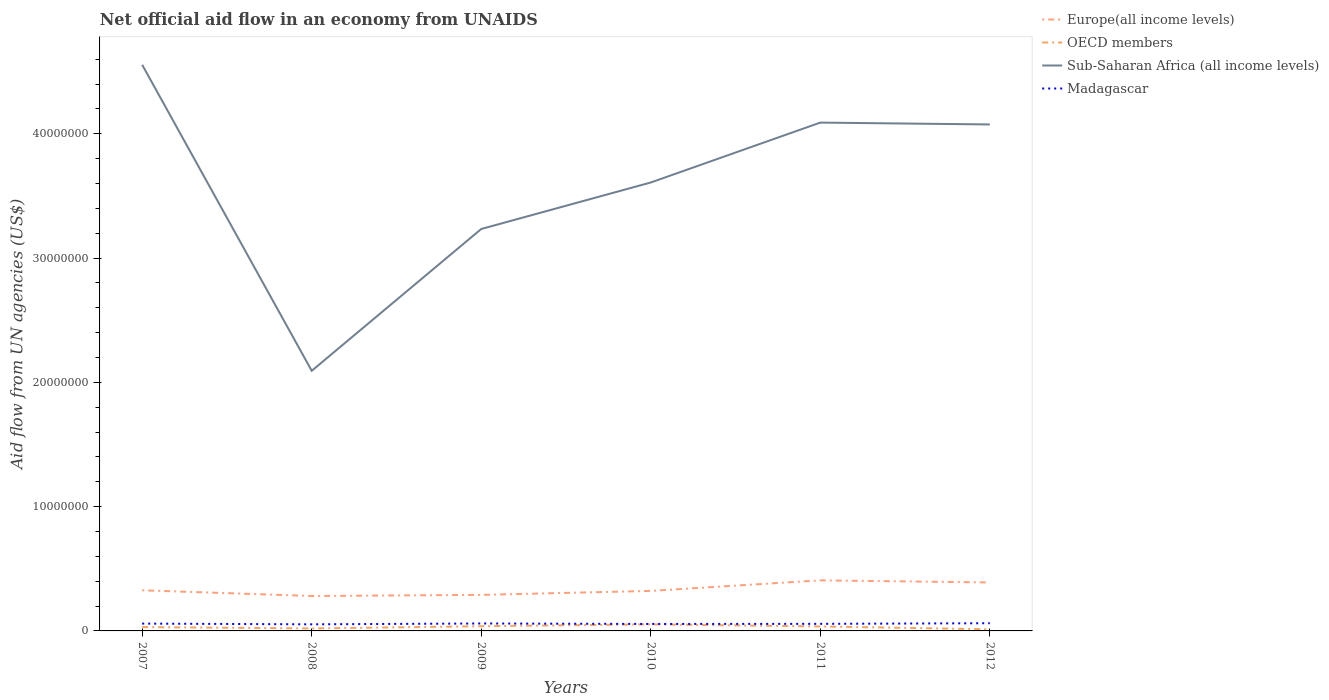How many different coloured lines are there?
Ensure brevity in your answer.  4. Is the number of lines equal to the number of legend labels?
Offer a terse response. Yes. Across all years, what is the maximum net official aid flow in OECD members?
Make the answer very short. 1.30e+05. What is the total net official aid flow in Madagascar in the graph?
Your answer should be compact. -9.00e+04. What is the difference between the highest and the second highest net official aid flow in OECD members?
Ensure brevity in your answer.  4.00e+05. Is the net official aid flow in Europe(all income levels) strictly greater than the net official aid flow in OECD members over the years?
Your response must be concise. No. How many years are there in the graph?
Your answer should be very brief. 6. Are the values on the major ticks of Y-axis written in scientific E-notation?
Provide a succinct answer. No. Does the graph contain any zero values?
Your answer should be very brief. No. Does the graph contain grids?
Offer a very short reply. No. Where does the legend appear in the graph?
Offer a very short reply. Top right. How many legend labels are there?
Offer a terse response. 4. How are the legend labels stacked?
Offer a terse response. Vertical. What is the title of the graph?
Offer a terse response. Net official aid flow in an economy from UNAIDS. Does "China" appear as one of the legend labels in the graph?
Your answer should be compact. No. What is the label or title of the Y-axis?
Ensure brevity in your answer.  Aid flow from UN agencies (US$). What is the Aid flow from UN agencies (US$) in Europe(all income levels) in 2007?
Provide a short and direct response. 3.27e+06. What is the Aid flow from UN agencies (US$) of Sub-Saharan Africa (all income levels) in 2007?
Provide a short and direct response. 4.56e+07. What is the Aid flow from UN agencies (US$) in Madagascar in 2007?
Offer a terse response. 5.90e+05. What is the Aid flow from UN agencies (US$) of Europe(all income levels) in 2008?
Make the answer very short. 2.81e+06. What is the Aid flow from UN agencies (US$) in Sub-Saharan Africa (all income levels) in 2008?
Your response must be concise. 2.09e+07. What is the Aid flow from UN agencies (US$) in Madagascar in 2008?
Your answer should be compact. 5.30e+05. What is the Aid flow from UN agencies (US$) in Europe(all income levels) in 2009?
Offer a very short reply. 2.90e+06. What is the Aid flow from UN agencies (US$) of Sub-Saharan Africa (all income levels) in 2009?
Give a very brief answer. 3.23e+07. What is the Aid flow from UN agencies (US$) in Europe(all income levels) in 2010?
Your response must be concise. 3.22e+06. What is the Aid flow from UN agencies (US$) of OECD members in 2010?
Give a very brief answer. 5.30e+05. What is the Aid flow from UN agencies (US$) of Sub-Saharan Africa (all income levels) in 2010?
Provide a short and direct response. 3.61e+07. What is the Aid flow from UN agencies (US$) of Madagascar in 2010?
Ensure brevity in your answer.  5.60e+05. What is the Aid flow from UN agencies (US$) in Europe(all income levels) in 2011?
Provide a short and direct response. 4.07e+06. What is the Aid flow from UN agencies (US$) of Sub-Saharan Africa (all income levels) in 2011?
Provide a short and direct response. 4.09e+07. What is the Aid flow from UN agencies (US$) in Madagascar in 2011?
Your answer should be compact. 5.70e+05. What is the Aid flow from UN agencies (US$) in Europe(all income levels) in 2012?
Give a very brief answer. 3.90e+06. What is the Aid flow from UN agencies (US$) of OECD members in 2012?
Give a very brief answer. 1.30e+05. What is the Aid flow from UN agencies (US$) of Sub-Saharan Africa (all income levels) in 2012?
Provide a short and direct response. 4.08e+07. What is the Aid flow from UN agencies (US$) in Madagascar in 2012?
Provide a succinct answer. 6.20e+05. Across all years, what is the maximum Aid flow from UN agencies (US$) of Europe(all income levels)?
Provide a succinct answer. 4.07e+06. Across all years, what is the maximum Aid flow from UN agencies (US$) of OECD members?
Provide a short and direct response. 5.30e+05. Across all years, what is the maximum Aid flow from UN agencies (US$) in Sub-Saharan Africa (all income levels)?
Give a very brief answer. 4.56e+07. Across all years, what is the maximum Aid flow from UN agencies (US$) of Madagascar?
Your answer should be compact. 6.20e+05. Across all years, what is the minimum Aid flow from UN agencies (US$) of Europe(all income levels)?
Offer a terse response. 2.81e+06. Across all years, what is the minimum Aid flow from UN agencies (US$) in OECD members?
Your answer should be compact. 1.30e+05. Across all years, what is the minimum Aid flow from UN agencies (US$) in Sub-Saharan Africa (all income levels)?
Your answer should be very brief. 2.09e+07. Across all years, what is the minimum Aid flow from UN agencies (US$) of Madagascar?
Your response must be concise. 5.30e+05. What is the total Aid flow from UN agencies (US$) of Europe(all income levels) in the graph?
Offer a terse response. 2.02e+07. What is the total Aid flow from UN agencies (US$) of OECD members in the graph?
Offer a very short reply. 1.91e+06. What is the total Aid flow from UN agencies (US$) of Sub-Saharan Africa (all income levels) in the graph?
Offer a very short reply. 2.17e+08. What is the total Aid flow from UN agencies (US$) in Madagascar in the graph?
Your answer should be very brief. 3.47e+06. What is the difference between the Aid flow from UN agencies (US$) of OECD members in 2007 and that in 2008?
Provide a short and direct response. 1.10e+05. What is the difference between the Aid flow from UN agencies (US$) in Sub-Saharan Africa (all income levels) in 2007 and that in 2008?
Give a very brief answer. 2.46e+07. What is the difference between the Aid flow from UN agencies (US$) of Madagascar in 2007 and that in 2008?
Provide a short and direct response. 6.00e+04. What is the difference between the Aid flow from UN agencies (US$) in Europe(all income levels) in 2007 and that in 2009?
Provide a short and direct response. 3.70e+05. What is the difference between the Aid flow from UN agencies (US$) in OECD members in 2007 and that in 2009?
Your response must be concise. -7.00e+04. What is the difference between the Aid flow from UN agencies (US$) in Sub-Saharan Africa (all income levels) in 2007 and that in 2009?
Offer a very short reply. 1.32e+07. What is the difference between the Aid flow from UN agencies (US$) in Sub-Saharan Africa (all income levels) in 2007 and that in 2010?
Provide a succinct answer. 9.47e+06. What is the difference between the Aid flow from UN agencies (US$) of Europe(all income levels) in 2007 and that in 2011?
Make the answer very short. -8.00e+05. What is the difference between the Aid flow from UN agencies (US$) in OECD members in 2007 and that in 2011?
Your response must be concise. -5.00e+04. What is the difference between the Aid flow from UN agencies (US$) of Sub-Saharan Africa (all income levels) in 2007 and that in 2011?
Give a very brief answer. 4.65e+06. What is the difference between the Aid flow from UN agencies (US$) of Europe(all income levels) in 2007 and that in 2012?
Your answer should be very brief. -6.30e+05. What is the difference between the Aid flow from UN agencies (US$) in Sub-Saharan Africa (all income levels) in 2007 and that in 2012?
Offer a very short reply. 4.80e+06. What is the difference between the Aid flow from UN agencies (US$) in Madagascar in 2007 and that in 2012?
Provide a short and direct response. -3.00e+04. What is the difference between the Aid flow from UN agencies (US$) in Europe(all income levels) in 2008 and that in 2009?
Make the answer very short. -9.00e+04. What is the difference between the Aid flow from UN agencies (US$) in OECD members in 2008 and that in 2009?
Offer a terse response. -1.80e+05. What is the difference between the Aid flow from UN agencies (US$) of Sub-Saharan Africa (all income levels) in 2008 and that in 2009?
Your response must be concise. -1.14e+07. What is the difference between the Aid flow from UN agencies (US$) in Madagascar in 2008 and that in 2009?
Give a very brief answer. -7.00e+04. What is the difference between the Aid flow from UN agencies (US$) in Europe(all income levels) in 2008 and that in 2010?
Provide a succinct answer. -4.10e+05. What is the difference between the Aid flow from UN agencies (US$) in OECD members in 2008 and that in 2010?
Keep it short and to the point. -3.30e+05. What is the difference between the Aid flow from UN agencies (US$) of Sub-Saharan Africa (all income levels) in 2008 and that in 2010?
Your response must be concise. -1.52e+07. What is the difference between the Aid flow from UN agencies (US$) of Madagascar in 2008 and that in 2010?
Keep it short and to the point. -3.00e+04. What is the difference between the Aid flow from UN agencies (US$) of Europe(all income levels) in 2008 and that in 2011?
Give a very brief answer. -1.26e+06. What is the difference between the Aid flow from UN agencies (US$) of OECD members in 2008 and that in 2011?
Your answer should be compact. -1.60e+05. What is the difference between the Aid flow from UN agencies (US$) in Sub-Saharan Africa (all income levels) in 2008 and that in 2011?
Ensure brevity in your answer.  -2.00e+07. What is the difference between the Aid flow from UN agencies (US$) of Europe(all income levels) in 2008 and that in 2012?
Provide a succinct answer. -1.09e+06. What is the difference between the Aid flow from UN agencies (US$) of Sub-Saharan Africa (all income levels) in 2008 and that in 2012?
Ensure brevity in your answer.  -1.98e+07. What is the difference between the Aid flow from UN agencies (US$) of Europe(all income levels) in 2009 and that in 2010?
Your answer should be compact. -3.20e+05. What is the difference between the Aid flow from UN agencies (US$) in Sub-Saharan Africa (all income levels) in 2009 and that in 2010?
Offer a very short reply. -3.74e+06. What is the difference between the Aid flow from UN agencies (US$) of Europe(all income levels) in 2009 and that in 2011?
Your response must be concise. -1.17e+06. What is the difference between the Aid flow from UN agencies (US$) in OECD members in 2009 and that in 2011?
Your answer should be very brief. 2.00e+04. What is the difference between the Aid flow from UN agencies (US$) of Sub-Saharan Africa (all income levels) in 2009 and that in 2011?
Keep it short and to the point. -8.56e+06. What is the difference between the Aid flow from UN agencies (US$) in Madagascar in 2009 and that in 2011?
Your response must be concise. 3.00e+04. What is the difference between the Aid flow from UN agencies (US$) in Sub-Saharan Africa (all income levels) in 2009 and that in 2012?
Keep it short and to the point. -8.41e+06. What is the difference between the Aid flow from UN agencies (US$) in Europe(all income levels) in 2010 and that in 2011?
Give a very brief answer. -8.50e+05. What is the difference between the Aid flow from UN agencies (US$) in Sub-Saharan Africa (all income levels) in 2010 and that in 2011?
Ensure brevity in your answer.  -4.82e+06. What is the difference between the Aid flow from UN agencies (US$) in Europe(all income levels) in 2010 and that in 2012?
Your answer should be very brief. -6.80e+05. What is the difference between the Aid flow from UN agencies (US$) in OECD members in 2010 and that in 2012?
Offer a terse response. 4.00e+05. What is the difference between the Aid flow from UN agencies (US$) in Sub-Saharan Africa (all income levels) in 2010 and that in 2012?
Your answer should be very brief. -4.67e+06. What is the difference between the Aid flow from UN agencies (US$) in Madagascar in 2010 and that in 2012?
Provide a short and direct response. -6.00e+04. What is the difference between the Aid flow from UN agencies (US$) of Madagascar in 2011 and that in 2012?
Provide a short and direct response. -5.00e+04. What is the difference between the Aid flow from UN agencies (US$) of Europe(all income levels) in 2007 and the Aid flow from UN agencies (US$) of OECD members in 2008?
Your response must be concise. 3.07e+06. What is the difference between the Aid flow from UN agencies (US$) of Europe(all income levels) in 2007 and the Aid flow from UN agencies (US$) of Sub-Saharan Africa (all income levels) in 2008?
Your answer should be very brief. -1.77e+07. What is the difference between the Aid flow from UN agencies (US$) of Europe(all income levels) in 2007 and the Aid flow from UN agencies (US$) of Madagascar in 2008?
Offer a terse response. 2.74e+06. What is the difference between the Aid flow from UN agencies (US$) of OECD members in 2007 and the Aid flow from UN agencies (US$) of Sub-Saharan Africa (all income levels) in 2008?
Your answer should be very brief. -2.06e+07. What is the difference between the Aid flow from UN agencies (US$) in Sub-Saharan Africa (all income levels) in 2007 and the Aid flow from UN agencies (US$) in Madagascar in 2008?
Keep it short and to the point. 4.50e+07. What is the difference between the Aid flow from UN agencies (US$) in Europe(all income levels) in 2007 and the Aid flow from UN agencies (US$) in OECD members in 2009?
Ensure brevity in your answer.  2.89e+06. What is the difference between the Aid flow from UN agencies (US$) in Europe(all income levels) in 2007 and the Aid flow from UN agencies (US$) in Sub-Saharan Africa (all income levels) in 2009?
Offer a very short reply. -2.91e+07. What is the difference between the Aid flow from UN agencies (US$) of Europe(all income levels) in 2007 and the Aid flow from UN agencies (US$) of Madagascar in 2009?
Make the answer very short. 2.67e+06. What is the difference between the Aid flow from UN agencies (US$) in OECD members in 2007 and the Aid flow from UN agencies (US$) in Sub-Saharan Africa (all income levels) in 2009?
Your answer should be very brief. -3.20e+07. What is the difference between the Aid flow from UN agencies (US$) in OECD members in 2007 and the Aid flow from UN agencies (US$) in Madagascar in 2009?
Offer a very short reply. -2.90e+05. What is the difference between the Aid flow from UN agencies (US$) of Sub-Saharan Africa (all income levels) in 2007 and the Aid flow from UN agencies (US$) of Madagascar in 2009?
Ensure brevity in your answer.  4.50e+07. What is the difference between the Aid flow from UN agencies (US$) of Europe(all income levels) in 2007 and the Aid flow from UN agencies (US$) of OECD members in 2010?
Your response must be concise. 2.74e+06. What is the difference between the Aid flow from UN agencies (US$) in Europe(all income levels) in 2007 and the Aid flow from UN agencies (US$) in Sub-Saharan Africa (all income levels) in 2010?
Your answer should be very brief. -3.28e+07. What is the difference between the Aid flow from UN agencies (US$) of Europe(all income levels) in 2007 and the Aid flow from UN agencies (US$) of Madagascar in 2010?
Your answer should be very brief. 2.71e+06. What is the difference between the Aid flow from UN agencies (US$) of OECD members in 2007 and the Aid flow from UN agencies (US$) of Sub-Saharan Africa (all income levels) in 2010?
Your answer should be compact. -3.58e+07. What is the difference between the Aid flow from UN agencies (US$) of Sub-Saharan Africa (all income levels) in 2007 and the Aid flow from UN agencies (US$) of Madagascar in 2010?
Provide a short and direct response. 4.50e+07. What is the difference between the Aid flow from UN agencies (US$) in Europe(all income levels) in 2007 and the Aid flow from UN agencies (US$) in OECD members in 2011?
Offer a very short reply. 2.91e+06. What is the difference between the Aid flow from UN agencies (US$) of Europe(all income levels) in 2007 and the Aid flow from UN agencies (US$) of Sub-Saharan Africa (all income levels) in 2011?
Provide a succinct answer. -3.76e+07. What is the difference between the Aid flow from UN agencies (US$) of Europe(all income levels) in 2007 and the Aid flow from UN agencies (US$) of Madagascar in 2011?
Provide a succinct answer. 2.70e+06. What is the difference between the Aid flow from UN agencies (US$) in OECD members in 2007 and the Aid flow from UN agencies (US$) in Sub-Saharan Africa (all income levels) in 2011?
Your answer should be compact. -4.06e+07. What is the difference between the Aid flow from UN agencies (US$) in Sub-Saharan Africa (all income levels) in 2007 and the Aid flow from UN agencies (US$) in Madagascar in 2011?
Keep it short and to the point. 4.50e+07. What is the difference between the Aid flow from UN agencies (US$) in Europe(all income levels) in 2007 and the Aid flow from UN agencies (US$) in OECD members in 2012?
Your response must be concise. 3.14e+06. What is the difference between the Aid flow from UN agencies (US$) in Europe(all income levels) in 2007 and the Aid flow from UN agencies (US$) in Sub-Saharan Africa (all income levels) in 2012?
Offer a very short reply. -3.75e+07. What is the difference between the Aid flow from UN agencies (US$) in Europe(all income levels) in 2007 and the Aid flow from UN agencies (US$) in Madagascar in 2012?
Keep it short and to the point. 2.65e+06. What is the difference between the Aid flow from UN agencies (US$) of OECD members in 2007 and the Aid flow from UN agencies (US$) of Sub-Saharan Africa (all income levels) in 2012?
Offer a terse response. -4.04e+07. What is the difference between the Aid flow from UN agencies (US$) of OECD members in 2007 and the Aid flow from UN agencies (US$) of Madagascar in 2012?
Keep it short and to the point. -3.10e+05. What is the difference between the Aid flow from UN agencies (US$) of Sub-Saharan Africa (all income levels) in 2007 and the Aid flow from UN agencies (US$) of Madagascar in 2012?
Offer a very short reply. 4.49e+07. What is the difference between the Aid flow from UN agencies (US$) of Europe(all income levels) in 2008 and the Aid flow from UN agencies (US$) of OECD members in 2009?
Provide a succinct answer. 2.43e+06. What is the difference between the Aid flow from UN agencies (US$) in Europe(all income levels) in 2008 and the Aid flow from UN agencies (US$) in Sub-Saharan Africa (all income levels) in 2009?
Your response must be concise. -2.95e+07. What is the difference between the Aid flow from UN agencies (US$) of Europe(all income levels) in 2008 and the Aid flow from UN agencies (US$) of Madagascar in 2009?
Keep it short and to the point. 2.21e+06. What is the difference between the Aid flow from UN agencies (US$) of OECD members in 2008 and the Aid flow from UN agencies (US$) of Sub-Saharan Africa (all income levels) in 2009?
Your answer should be very brief. -3.21e+07. What is the difference between the Aid flow from UN agencies (US$) in OECD members in 2008 and the Aid flow from UN agencies (US$) in Madagascar in 2009?
Ensure brevity in your answer.  -4.00e+05. What is the difference between the Aid flow from UN agencies (US$) of Sub-Saharan Africa (all income levels) in 2008 and the Aid flow from UN agencies (US$) of Madagascar in 2009?
Provide a succinct answer. 2.03e+07. What is the difference between the Aid flow from UN agencies (US$) of Europe(all income levels) in 2008 and the Aid flow from UN agencies (US$) of OECD members in 2010?
Your answer should be compact. 2.28e+06. What is the difference between the Aid flow from UN agencies (US$) of Europe(all income levels) in 2008 and the Aid flow from UN agencies (US$) of Sub-Saharan Africa (all income levels) in 2010?
Make the answer very short. -3.33e+07. What is the difference between the Aid flow from UN agencies (US$) of Europe(all income levels) in 2008 and the Aid flow from UN agencies (US$) of Madagascar in 2010?
Provide a short and direct response. 2.25e+06. What is the difference between the Aid flow from UN agencies (US$) in OECD members in 2008 and the Aid flow from UN agencies (US$) in Sub-Saharan Africa (all income levels) in 2010?
Your response must be concise. -3.59e+07. What is the difference between the Aid flow from UN agencies (US$) in OECD members in 2008 and the Aid flow from UN agencies (US$) in Madagascar in 2010?
Keep it short and to the point. -3.60e+05. What is the difference between the Aid flow from UN agencies (US$) in Sub-Saharan Africa (all income levels) in 2008 and the Aid flow from UN agencies (US$) in Madagascar in 2010?
Provide a succinct answer. 2.04e+07. What is the difference between the Aid flow from UN agencies (US$) in Europe(all income levels) in 2008 and the Aid flow from UN agencies (US$) in OECD members in 2011?
Provide a succinct answer. 2.45e+06. What is the difference between the Aid flow from UN agencies (US$) of Europe(all income levels) in 2008 and the Aid flow from UN agencies (US$) of Sub-Saharan Africa (all income levels) in 2011?
Give a very brief answer. -3.81e+07. What is the difference between the Aid flow from UN agencies (US$) in Europe(all income levels) in 2008 and the Aid flow from UN agencies (US$) in Madagascar in 2011?
Keep it short and to the point. 2.24e+06. What is the difference between the Aid flow from UN agencies (US$) of OECD members in 2008 and the Aid flow from UN agencies (US$) of Sub-Saharan Africa (all income levels) in 2011?
Your answer should be compact. -4.07e+07. What is the difference between the Aid flow from UN agencies (US$) of OECD members in 2008 and the Aid flow from UN agencies (US$) of Madagascar in 2011?
Make the answer very short. -3.70e+05. What is the difference between the Aid flow from UN agencies (US$) of Sub-Saharan Africa (all income levels) in 2008 and the Aid flow from UN agencies (US$) of Madagascar in 2011?
Your answer should be compact. 2.04e+07. What is the difference between the Aid flow from UN agencies (US$) in Europe(all income levels) in 2008 and the Aid flow from UN agencies (US$) in OECD members in 2012?
Offer a terse response. 2.68e+06. What is the difference between the Aid flow from UN agencies (US$) of Europe(all income levels) in 2008 and the Aid flow from UN agencies (US$) of Sub-Saharan Africa (all income levels) in 2012?
Give a very brief answer. -3.79e+07. What is the difference between the Aid flow from UN agencies (US$) of Europe(all income levels) in 2008 and the Aid flow from UN agencies (US$) of Madagascar in 2012?
Give a very brief answer. 2.19e+06. What is the difference between the Aid flow from UN agencies (US$) of OECD members in 2008 and the Aid flow from UN agencies (US$) of Sub-Saharan Africa (all income levels) in 2012?
Your answer should be very brief. -4.06e+07. What is the difference between the Aid flow from UN agencies (US$) in OECD members in 2008 and the Aid flow from UN agencies (US$) in Madagascar in 2012?
Provide a short and direct response. -4.20e+05. What is the difference between the Aid flow from UN agencies (US$) in Sub-Saharan Africa (all income levels) in 2008 and the Aid flow from UN agencies (US$) in Madagascar in 2012?
Your answer should be very brief. 2.03e+07. What is the difference between the Aid flow from UN agencies (US$) of Europe(all income levels) in 2009 and the Aid flow from UN agencies (US$) of OECD members in 2010?
Give a very brief answer. 2.37e+06. What is the difference between the Aid flow from UN agencies (US$) of Europe(all income levels) in 2009 and the Aid flow from UN agencies (US$) of Sub-Saharan Africa (all income levels) in 2010?
Make the answer very short. -3.32e+07. What is the difference between the Aid flow from UN agencies (US$) of Europe(all income levels) in 2009 and the Aid flow from UN agencies (US$) of Madagascar in 2010?
Give a very brief answer. 2.34e+06. What is the difference between the Aid flow from UN agencies (US$) in OECD members in 2009 and the Aid flow from UN agencies (US$) in Sub-Saharan Africa (all income levels) in 2010?
Provide a short and direct response. -3.57e+07. What is the difference between the Aid flow from UN agencies (US$) of OECD members in 2009 and the Aid flow from UN agencies (US$) of Madagascar in 2010?
Give a very brief answer. -1.80e+05. What is the difference between the Aid flow from UN agencies (US$) of Sub-Saharan Africa (all income levels) in 2009 and the Aid flow from UN agencies (US$) of Madagascar in 2010?
Make the answer very short. 3.18e+07. What is the difference between the Aid flow from UN agencies (US$) of Europe(all income levels) in 2009 and the Aid flow from UN agencies (US$) of OECD members in 2011?
Your answer should be compact. 2.54e+06. What is the difference between the Aid flow from UN agencies (US$) of Europe(all income levels) in 2009 and the Aid flow from UN agencies (US$) of Sub-Saharan Africa (all income levels) in 2011?
Your answer should be compact. -3.80e+07. What is the difference between the Aid flow from UN agencies (US$) of Europe(all income levels) in 2009 and the Aid flow from UN agencies (US$) of Madagascar in 2011?
Offer a terse response. 2.33e+06. What is the difference between the Aid flow from UN agencies (US$) of OECD members in 2009 and the Aid flow from UN agencies (US$) of Sub-Saharan Africa (all income levels) in 2011?
Offer a very short reply. -4.05e+07. What is the difference between the Aid flow from UN agencies (US$) of OECD members in 2009 and the Aid flow from UN agencies (US$) of Madagascar in 2011?
Make the answer very short. -1.90e+05. What is the difference between the Aid flow from UN agencies (US$) of Sub-Saharan Africa (all income levels) in 2009 and the Aid flow from UN agencies (US$) of Madagascar in 2011?
Make the answer very short. 3.18e+07. What is the difference between the Aid flow from UN agencies (US$) of Europe(all income levels) in 2009 and the Aid flow from UN agencies (US$) of OECD members in 2012?
Your answer should be very brief. 2.77e+06. What is the difference between the Aid flow from UN agencies (US$) in Europe(all income levels) in 2009 and the Aid flow from UN agencies (US$) in Sub-Saharan Africa (all income levels) in 2012?
Keep it short and to the point. -3.78e+07. What is the difference between the Aid flow from UN agencies (US$) of Europe(all income levels) in 2009 and the Aid flow from UN agencies (US$) of Madagascar in 2012?
Make the answer very short. 2.28e+06. What is the difference between the Aid flow from UN agencies (US$) of OECD members in 2009 and the Aid flow from UN agencies (US$) of Sub-Saharan Africa (all income levels) in 2012?
Provide a short and direct response. -4.04e+07. What is the difference between the Aid flow from UN agencies (US$) of OECD members in 2009 and the Aid flow from UN agencies (US$) of Madagascar in 2012?
Offer a terse response. -2.40e+05. What is the difference between the Aid flow from UN agencies (US$) of Sub-Saharan Africa (all income levels) in 2009 and the Aid flow from UN agencies (US$) of Madagascar in 2012?
Offer a terse response. 3.17e+07. What is the difference between the Aid flow from UN agencies (US$) in Europe(all income levels) in 2010 and the Aid flow from UN agencies (US$) in OECD members in 2011?
Your response must be concise. 2.86e+06. What is the difference between the Aid flow from UN agencies (US$) in Europe(all income levels) in 2010 and the Aid flow from UN agencies (US$) in Sub-Saharan Africa (all income levels) in 2011?
Your answer should be compact. -3.77e+07. What is the difference between the Aid flow from UN agencies (US$) in Europe(all income levels) in 2010 and the Aid flow from UN agencies (US$) in Madagascar in 2011?
Make the answer very short. 2.65e+06. What is the difference between the Aid flow from UN agencies (US$) in OECD members in 2010 and the Aid flow from UN agencies (US$) in Sub-Saharan Africa (all income levels) in 2011?
Your answer should be compact. -4.04e+07. What is the difference between the Aid flow from UN agencies (US$) in Sub-Saharan Africa (all income levels) in 2010 and the Aid flow from UN agencies (US$) in Madagascar in 2011?
Offer a terse response. 3.55e+07. What is the difference between the Aid flow from UN agencies (US$) of Europe(all income levels) in 2010 and the Aid flow from UN agencies (US$) of OECD members in 2012?
Ensure brevity in your answer.  3.09e+06. What is the difference between the Aid flow from UN agencies (US$) of Europe(all income levels) in 2010 and the Aid flow from UN agencies (US$) of Sub-Saharan Africa (all income levels) in 2012?
Provide a succinct answer. -3.75e+07. What is the difference between the Aid flow from UN agencies (US$) in Europe(all income levels) in 2010 and the Aid flow from UN agencies (US$) in Madagascar in 2012?
Offer a very short reply. 2.60e+06. What is the difference between the Aid flow from UN agencies (US$) in OECD members in 2010 and the Aid flow from UN agencies (US$) in Sub-Saharan Africa (all income levels) in 2012?
Provide a short and direct response. -4.02e+07. What is the difference between the Aid flow from UN agencies (US$) of OECD members in 2010 and the Aid flow from UN agencies (US$) of Madagascar in 2012?
Give a very brief answer. -9.00e+04. What is the difference between the Aid flow from UN agencies (US$) in Sub-Saharan Africa (all income levels) in 2010 and the Aid flow from UN agencies (US$) in Madagascar in 2012?
Offer a very short reply. 3.55e+07. What is the difference between the Aid flow from UN agencies (US$) in Europe(all income levels) in 2011 and the Aid flow from UN agencies (US$) in OECD members in 2012?
Your answer should be very brief. 3.94e+06. What is the difference between the Aid flow from UN agencies (US$) in Europe(all income levels) in 2011 and the Aid flow from UN agencies (US$) in Sub-Saharan Africa (all income levels) in 2012?
Your answer should be very brief. -3.67e+07. What is the difference between the Aid flow from UN agencies (US$) in Europe(all income levels) in 2011 and the Aid flow from UN agencies (US$) in Madagascar in 2012?
Ensure brevity in your answer.  3.45e+06. What is the difference between the Aid flow from UN agencies (US$) of OECD members in 2011 and the Aid flow from UN agencies (US$) of Sub-Saharan Africa (all income levels) in 2012?
Offer a very short reply. -4.04e+07. What is the difference between the Aid flow from UN agencies (US$) in Sub-Saharan Africa (all income levels) in 2011 and the Aid flow from UN agencies (US$) in Madagascar in 2012?
Provide a short and direct response. 4.03e+07. What is the average Aid flow from UN agencies (US$) of Europe(all income levels) per year?
Your answer should be compact. 3.36e+06. What is the average Aid flow from UN agencies (US$) in OECD members per year?
Offer a terse response. 3.18e+05. What is the average Aid flow from UN agencies (US$) of Sub-Saharan Africa (all income levels) per year?
Offer a very short reply. 3.61e+07. What is the average Aid flow from UN agencies (US$) in Madagascar per year?
Your answer should be very brief. 5.78e+05. In the year 2007, what is the difference between the Aid flow from UN agencies (US$) of Europe(all income levels) and Aid flow from UN agencies (US$) of OECD members?
Your response must be concise. 2.96e+06. In the year 2007, what is the difference between the Aid flow from UN agencies (US$) of Europe(all income levels) and Aid flow from UN agencies (US$) of Sub-Saharan Africa (all income levels)?
Your answer should be compact. -4.23e+07. In the year 2007, what is the difference between the Aid flow from UN agencies (US$) in Europe(all income levels) and Aid flow from UN agencies (US$) in Madagascar?
Offer a terse response. 2.68e+06. In the year 2007, what is the difference between the Aid flow from UN agencies (US$) in OECD members and Aid flow from UN agencies (US$) in Sub-Saharan Africa (all income levels)?
Give a very brief answer. -4.52e+07. In the year 2007, what is the difference between the Aid flow from UN agencies (US$) of OECD members and Aid flow from UN agencies (US$) of Madagascar?
Offer a very short reply. -2.80e+05. In the year 2007, what is the difference between the Aid flow from UN agencies (US$) of Sub-Saharan Africa (all income levels) and Aid flow from UN agencies (US$) of Madagascar?
Give a very brief answer. 4.50e+07. In the year 2008, what is the difference between the Aid flow from UN agencies (US$) in Europe(all income levels) and Aid flow from UN agencies (US$) in OECD members?
Make the answer very short. 2.61e+06. In the year 2008, what is the difference between the Aid flow from UN agencies (US$) of Europe(all income levels) and Aid flow from UN agencies (US$) of Sub-Saharan Africa (all income levels)?
Keep it short and to the point. -1.81e+07. In the year 2008, what is the difference between the Aid flow from UN agencies (US$) in Europe(all income levels) and Aid flow from UN agencies (US$) in Madagascar?
Provide a short and direct response. 2.28e+06. In the year 2008, what is the difference between the Aid flow from UN agencies (US$) in OECD members and Aid flow from UN agencies (US$) in Sub-Saharan Africa (all income levels)?
Provide a short and direct response. -2.07e+07. In the year 2008, what is the difference between the Aid flow from UN agencies (US$) in OECD members and Aid flow from UN agencies (US$) in Madagascar?
Provide a short and direct response. -3.30e+05. In the year 2008, what is the difference between the Aid flow from UN agencies (US$) in Sub-Saharan Africa (all income levels) and Aid flow from UN agencies (US$) in Madagascar?
Give a very brief answer. 2.04e+07. In the year 2009, what is the difference between the Aid flow from UN agencies (US$) of Europe(all income levels) and Aid flow from UN agencies (US$) of OECD members?
Your response must be concise. 2.52e+06. In the year 2009, what is the difference between the Aid flow from UN agencies (US$) in Europe(all income levels) and Aid flow from UN agencies (US$) in Sub-Saharan Africa (all income levels)?
Your response must be concise. -2.94e+07. In the year 2009, what is the difference between the Aid flow from UN agencies (US$) in Europe(all income levels) and Aid flow from UN agencies (US$) in Madagascar?
Provide a succinct answer. 2.30e+06. In the year 2009, what is the difference between the Aid flow from UN agencies (US$) in OECD members and Aid flow from UN agencies (US$) in Sub-Saharan Africa (all income levels)?
Give a very brief answer. -3.20e+07. In the year 2009, what is the difference between the Aid flow from UN agencies (US$) in OECD members and Aid flow from UN agencies (US$) in Madagascar?
Keep it short and to the point. -2.20e+05. In the year 2009, what is the difference between the Aid flow from UN agencies (US$) in Sub-Saharan Africa (all income levels) and Aid flow from UN agencies (US$) in Madagascar?
Provide a short and direct response. 3.17e+07. In the year 2010, what is the difference between the Aid flow from UN agencies (US$) in Europe(all income levels) and Aid flow from UN agencies (US$) in OECD members?
Make the answer very short. 2.69e+06. In the year 2010, what is the difference between the Aid flow from UN agencies (US$) in Europe(all income levels) and Aid flow from UN agencies (US$) in Sub-Saharan Africa (all income levels)?
Your response must be concise. -3.29e+07. In the year 2010, what is the difference between the Aid flow from UN agencies (US$) of Europe(all income levels) and Aid flow from UN agencies (US$) of Madagascar?
Your answer should be compact. 2.66e+06. In the year 2010, what is the difference between the Aid flow from UN agencies (US$) of OECD members and Aid flow from UN agencies (US$) of Sub-Saharan Africa (all income levels)?
Provide a succinct answer. -3.56e+07. In the year 2010, what is the difference between the Aid flow from UN agencies (US$) of OECD members and Aid flow from UN agencies (US$) of Madagascar?
Offer a very short reply. -3.00e+04. In the year 2010, what is the difference between the Aid flow from UN agencies (US$) in Sub-Saharan Africa (all income levels) and Aid flow from UN agencies (US$) in Madagascar?
Make the answer very short. 3.55e+07. In the year 2011, what is the difference between the Aid flow from UN agencies (US$) of Europe(all income levels) and Aid flow from UN agencies (US$) of OECD members?
Offer a terse response. 3.71e+06. In the year 2011, what is the difference between the Aid flow from UN agencies (US$) in Europe(all income levels) and Aid flow from UN agencies (US$) in Sub-Saharan Africa (all income levels)?
Give a very brief answer. -3.68e+07. In the year 2011, what is the difference between the Aid flow from UN agencies (US$) in Europe(all income levels) and Aid flow from UN agencies (US$) in Madagascar?
Offer a terse response. 3.50e+06. In the year 2011, what is the difference between the Aid flow from UN agencies (US$) in OECD members and Aid flow from UN agencies (US$) in Sub-Saharan Africa (all income levels)?
Make the answer very short. -4.05e+07. In the year 2011, what is the difference between the Aid flow from UN agencies (US$) in Sub-Saharan Africa (all income levels) and Aid flow from UN agencies (US$) in Madagascar?
Give a very brief answer. 4.03e+07. In the year 2012, what is the difference between the Aid flow from UN agencies (US$) in Europe(all income levels) and Aid flow from UN agencies (US$) in OECD members?
Keep it short and to the point. 3.77e+06. In the year 2012, what is the difference between the Aid flow from UN agencies (US$) of Europe(all income levels) and Aid flow from UN agencies (US$) of Sub-Saharan Africa (all income levels)?
Ensure brevity in your answer.  -3.68e+07. In the year 2012, what is the difference between the Aid flow from UN agencies (US$) of Europe(all income levels) and Aid flow from UN agencies (US$) of Madagascar?
Your answer should be compact. 3.28e+06. In the year 2012, what is the difference between the Aid flow from UN agencies (US$) in OECD members and Aid flow from UN agencies (US$) in Sub-Saharan Africa (all income levels)?
Make the answer very short. -4.06e+07. In the year 2012, what is the difference between the Aid flow from UN agencies (US$) in OECD members and Aid flow from UN agencies (US$) in Madagascar?
Offer a very short reply. -4.90e+05. In the year 2012, what is the difference between the Aid flow from UN agencies (US$) of Sub-Saharan Africa (all income levels) and Aid flow from UN agencies (US$) of Madagascar?
Ensure brevity in your answer.  4.01e+07. What is the ratio of the Aid flow from UN agencies (US$) in Europe(all income levels) in 2007 to that in 2008?
Keep it short and to the point. 1.16. What is the ratio of the Aid flow from UN agencies (US$) in OECD members in 2007 to that in 2008?
Provide a succinct answer. 1.55. What is the ratio of the Aid flow from UN agencies (US$) of Sub-Saharan Africa (all income levels) in 2007 to that in 2008?
Make the answer very short. 2.18. What is the ratio of the Aid flow from UN agencies (US$) of Madagascar in 2007 to that in 2008?
Keep it short and to the point. 1.11. What is the ratio of the Aid flow from UN agencies (US$) of Europe(all income levels) in 2007 to that in 2009?
Your response must be concise. 1.13. What is the ratio of the Aid flow from UN agencies (US$) of OECD members in 2007 to that in 2009?
Keep it short and to the point. 0.82. What is the ratio of the Aid flow from UN agencies (US$) of Sub-Saharan Africa (all income levels) in 2007 to that in 2009?
Keep it short and to the point. 1.41. What is the ratio of the Aid flow from UN agencies (US$) in Madagascar in 2007 to that in 2009?
Make the answer very short. 0.98. What is the ratio of the Aid flow from UN agencies (US$) of Europe(all income levels) in 2007 to that in 2010?
Your answer should be very brief. 1.02. What is the ratio of the Aid flow from UN agencies (US$) in OECD members in 2007 to that in 2010?
Your answer should be very brief. 0.58. What is the ratio of the Aid flow from UN agencies (US$) of Sub-Saharan Africa (all income levels) in 2007 to that in 2010?
Provide a succinct answer. 1.26. What is the ratio of the Aid flow from UN agencies (US$) of Madagascar in 2007 to that in 2010?
Offer a very short reply. 1.05. What is the ratio of the Aid flow from UN agencies (US$) in Europe(all income levels) in 2007 to that in 2011?
Offer a terse response. 0.8. What is the ratio of the Aid flow from UN agencies (US$) of OECD members in 2007 to that in 2011?
Offer a very short reply. 0.86. What is the ratio of the Aid flow from UN agencies (US$) in Sub-Saharan Africa (all income levels) in 2007 to that in 2011?
Make the answer very short. 1.11. What is the ratio of the Aid flow from UN agencies (US$) of Madagascar in 2007 to that in 2011?
Provide a short and direct response. 1.04. What is the ratio of the Aid flow from UN agencies (US$) in Europe(all income levels) in 2007 to that in 2012?
Your answer should be compact. 0.84. What is the ratio of the Aid flow from UN agencies (US$) in OECD members in 2007 to that in 2012?
Offer a very short reply. 2.38. What is the ratio of the Aid flow from UN agencies (US$) of Sub-Saharan Africa (all income levels) in 2007 to that in 2012?
Offer a very short reply. 1.12. What is the ratio of the Aid flow from UN agencies (US$) of Madagascar in 2007 to that in 2012?
Give a very brief answer. 0.95. What is the ratio of the Aid flow from UN agencies (US$) of Europe(all income levels) in 2008 to that in 2009?
Your answer should be very brief. 0.97. What is the ratio of the Aid flow from UN agencies (US$) of OECD members in 2008 to that in 2009?
Make the answer very short. 0.53. What is the ratio of the Aid flow from UN agencies (US$) of Sub-Saharan Africa (all income levels) in 2008 to that in 2009?
Keep it short and to the point. 0.65. What is the ratio of the Aid flow from UN agencies (US$) in Madagascar in 2008 to that in 2009?
Provide a succinct answer. 0.88. What is the ratio of the Aid flow from UN agencies (US$) of Europe(all income levels) in 2008 to that in 2010?
Provide a succinct answer. 0.87. What is the ratio of the Aid flow from UN agencies (US$) in OECD members in 2008 to that in 2010?
Make the answer very short. 0.38. What is the ratio of the Aid flow from UN agencies (US$) in Sub-Saharan Africa (all income levels) in 2008 to that in 2010?
Give a very brief answer. 0.58. What is the ratio of the Aid flow from UN agencies (US$) of Madagascar in 2008 to that in 2010?
Your response must be concise. 0.95. What is the ratio of the Aid flow from UN agencies (US$) of Europe(all income levels) in 2008 to that in 2011?
Keep it short and to the point. 0.69. What is the ratio of the Aid flow from UN agencies (US$) of OECD members in 2008 to that in 2011?
Offer a terse response. 0.56. What is the ratio of the Aid flow from UN agencies (US$) in Sub-Saharan Africa (all income levels) in 2008 to that in 2011?
Your answer should be compact. 0.51. What is the ratio of the Aid flow from UN agencies (US$) of Madagascar in 2008 to that in 2011?
Offer a terse response. 0.93. What is the ratio of the Aid flow from UN agencies (US$) of Europe(all income levels) in 2008 to that in 2012?
Your answer should be compact. 0.72. What is the ratio of the Aid flow from UN agencies (US$) in OECD members in 2008 to that in 2012?
Ensure brevity in your answer.  1.54. What is the ratio of the Aid flow from UN agencies (US$) in Sub-Saharan Africa (all income levels) in 2008 to that in 2012?
Your answer should be compact. 0.51. What is the ratio of the Aid flow from UN agencies (US$) of Madagascar in 2008 to that in 2012?
Provide a succinct answer. 0.85. What is the ratio of the Aid flow from UN agencies (US$) of Europe(all income levels) in 2009 to that in 2010?
Keep it short and to the point. 0.9. What is the ratio of the Aid flow from UN agencies (US$) of OECD members in 2009 to that in 2010?
Your answer should be compact. 0.72. What is the ratio of the Aid flow from UN agencies (US$) of Sub-Saharan Africa (all income levels) in 2009 to that in 2010?
Ensure brevity in your answer.  0.9. What is the ratio of the Aid flow from UN agencies (US$) in Madagascar in 2009 to that in 2010?
Offer a terse response. 1.07. What is the ratio of the Aid flow from UN agencies (US$) of Europe(all income levels) in 2009 to that in 2011?
Keep it short and to the point. 0.71. What is the ratio of the Aid flow from UN agencies (US$) in OECD members in 2009 to that in 2011?
Provide a short and direct response. 1.06. What is the ratio of the Aid flow from UN agencies (US$) of Sub-Saharan Africa (all income levels) in 2009 to that in 2011?
Your answer should be compact. 0.79. What is the ratio of the Aid flow from UN agencies (US$) in Madagascar in 2009 to that in 2011?
Your response must be concise. 1.05. What is the ratio of the Aid flow from UN agencies (US$) of Europe(all income levels) in 2009 to that in 2012?
Ensure brevity in your answer.  0.74. What is the ratio of the Aid flow from UN agencies (US$) of OECD members in 2009 to that in 2012?
Provide a short and direct response. 2.92. What is the ratio of the Aid flow from UN agencies (US$) in Sub-Saharan Africa (all income levels) in 2009 to that in 2012?
Provide a short and direct response. 0.79. What is the ratio of the Aid flow from UN agencies (US$) of Europe(all income levels) in 2010 to that in 2011?
Make the answer very short. 0.79. What is the ratio of the Aid flow from UN agencies (US$) in OECD members in 2010 to that in 2011?
Offer a very short reply. 1.47. What is the ratio of the Aid flow from UN agencies (US$) of Sub-Saharan Africa (all income levels) in 2010 to that in 2011?
Provide a succinct answer. 0.88. What is the ratio of the Aid flow from UN agencies (US$) in Madagascar in 2010 to that in 2011?
Your answer should be very brief. 0.98. What is the ratio of the Aid flow from UN agencies (US$) of Europe(all income levels) in 2010 to that in 2012?
Your answer should be very brief. 0.83. What is the ratio of the Aid flow from UN agencies (US$) in OECD members in 2010 to that in 2012?
Your answer should be very brief. 4.08. What is the ratio of the Aid flow from UN agencies (US$) of Sub-Saharan Africa (all income levels) in 2010 to that in 2012?
Give a very brief answer. 0.89. What is the ratio of the Aid flow from UN agencies (US$) of Madagascar in 2010 to that in 2012?
Your response must be concise. 0.9. What is the ratio of the Aid flow from UN agencies (US$) of Europe(all income levels) in 2011 to that in 2012?
Give a very brief answer. 1.04. What is the ratio of the Aid flow from UN agencies (US$) of OECD members in 2011 to that in 2012?
Give a very brief answer. 2.77. What is the ratio of the Aid flow from UN agencies (US$) in Sub-Saharan Africa (all income levels) in 2011 to that in 2012?
Your response must be concise. 1. What is the ratio of the Aid flow from UN agencies (US$) in Madagascar in 2011 to that in 2012?
Your answer should be very brief. 0.92. What is the difference between the highest and the second highest Aid flow from UN agencies (US$) in Sub-Saharan Africa (all income levels)?
Keep it short and to the point. 4.65e+06. What is the difference between the highest and the second highest Aid flow from UN agencies (US$) of Madagascar?
Your answer should be very brief. 2.00e+04. What is the difference between the highest and the lowest Aid flow from UN agencies (US$) of Europe(all income levels)?
Provide a short and direct response. 1.26e+06. What is the difference between the highest and the lowest Aid flow from UN agencies (US$) in Sub-Saharan Africa (all income levels)?
Your answer should be very brief. 2.46e+07. What is the difference between the highest and the lowest Aid flow from UN agencies (US$) in Madagascar?
Provide a short and direct response. 9.00e+04. 